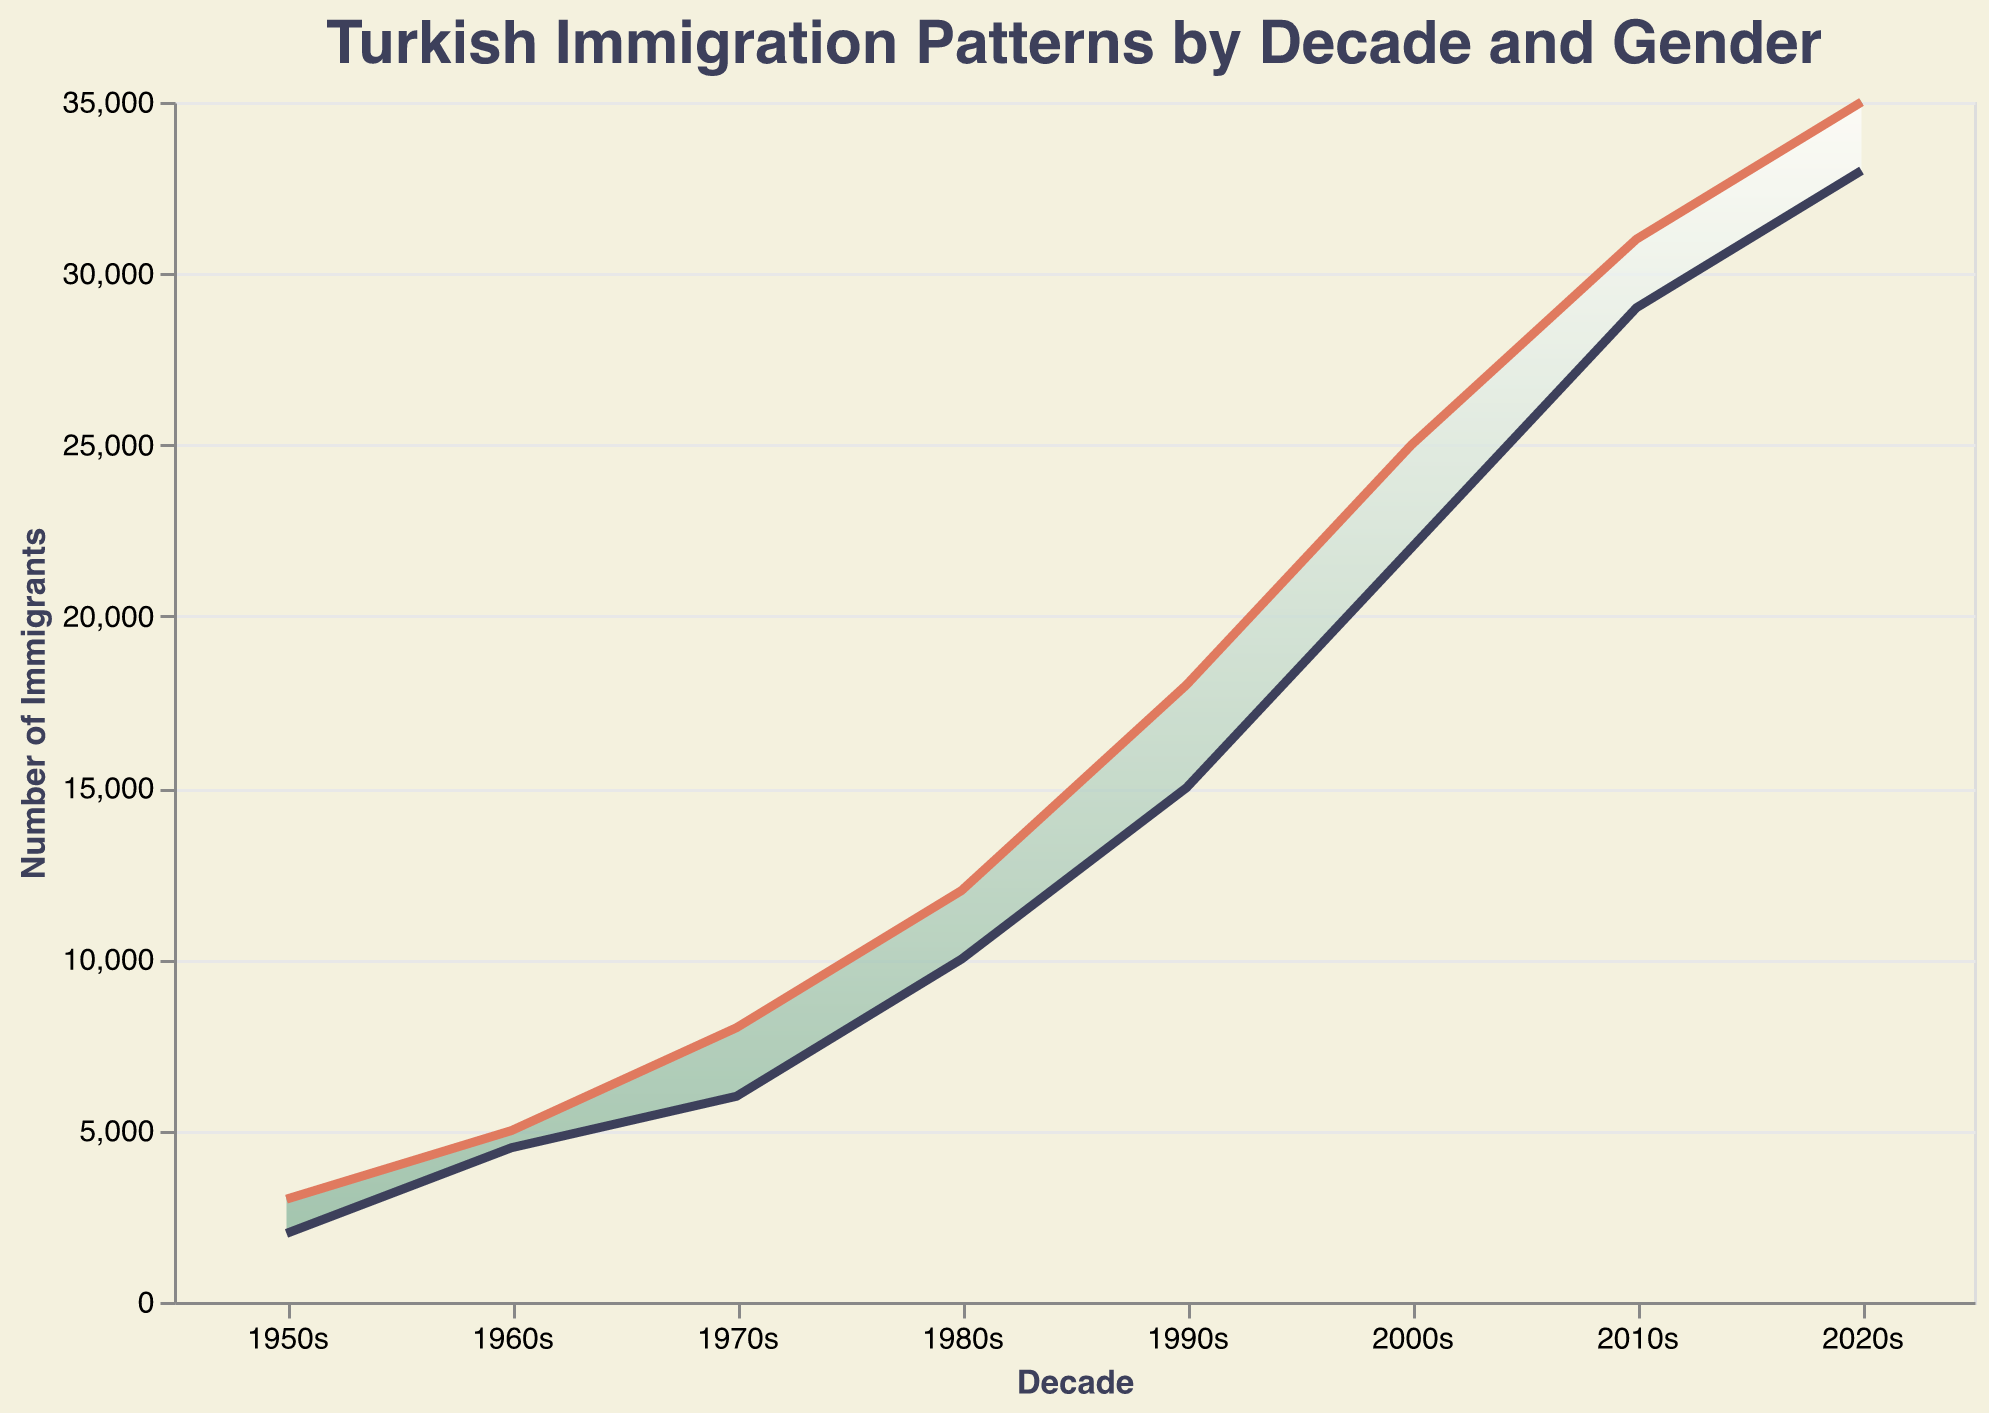What is the title of the chart? The title is displayed at the top of the chart.
Answer: Turkish Immigration Patterns by Decade and Gender How many decades are represented in the chart? The x-axis labels each decade, from the 1950s to the 2020s.
Answer: 8 In which decade did the number of male immigrants exceed 10,000 for the first time? Look at the male immigration line (green line) and find the first point where it crosses the 10,000 mark on the y-axis.
Answer: 1980s What is the difference in the number of male immigrants between the 1970s and 1980s? The chart shows 8,000 male immigrants in the 1970s and 12,000 in the 1980s. The difference is 12,000 - 8,000.
Answer: 4,000 Which decade saw the greatest increase in female immigrants compared to the previous decade? Calculate the increase for each decade by subtracting the number of female immigrants in the previous decade. Compare these values to find the maximum.
Answer: 2010s In which decade did the number of female immigrants reach 20,000 for the first time? Look at the female immigration line (blue line) and find the first point where it crosses the 20,000 mark on the y-axis.
Answer: 2000s By how much did the total number of immigrants (male and female combined) increase from the 1960s to the 1970s? Add the number of male and female immigrants for each decade and then subtract the total of the 1960s from the total of the 1970s. (8000+6000) - (5000+4500)
Answer: 4,500 Which gender had a smaller increase in the number of immigrants from the 1990s to the 2000s? Compare the difference in numbers for each gender between the 1990s and 2000s: (25000-18000) for males and (22000-15000) for females.
Answer: Female What was the total number of immigrants (male and female) in the 2020s? Add the number of male and female immigrants for the 2020s (35000 + 33000).
Answer: 68,000 How does the trend of male immigrants compare to female immigrants over the decades? Observe the lines representing male (green) and female (blue). Both lines show an increasing trend, with males consistently higher than females, and a narrowing gap in recent decades.
Answer: Both increase, males consistently higher, gap narrows 